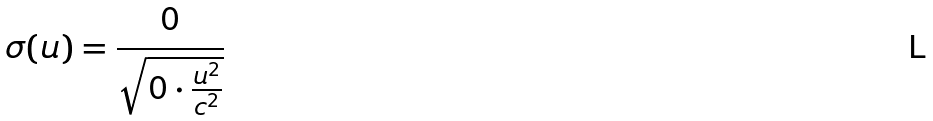Convert formula to latex. <formula><loc_0><loc_0><loc_500><loc_500>\sigma ( u ) = \frac { 0 } { \sqrt { 0 \cdot \frac { u ^ { 2 } } { c ^ { 2 } } } }</formula> 